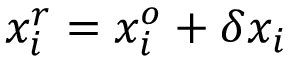Convert formula to latex. <formula><loc_0><loc_0><loc_500><loc_500>x _ { i } ^ { r } = x _ { i } ^ { o } + \delta x _ { i }</formula> 